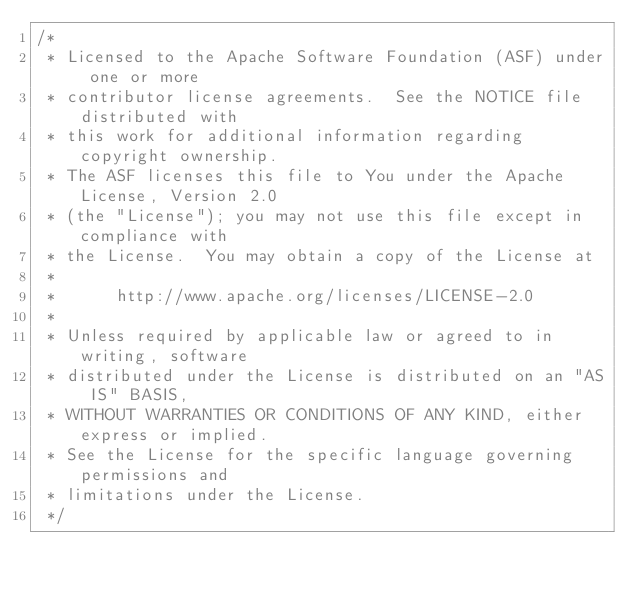Convert code to text. <code><loc_0><loc_0><loc_500><loc_500><_Java_>/*
 * Licensed to the Apache Software Foundation (ASF) under one or more
 * contributor license agreements.  See the NOTICE file distributed with
 * this work for additional information regarding copyright ownership.
 * The ASF licenses this file to You under the Apache License, Version 2.0
 * (the "License"); you may not use this file except in compliance with
 * the License.  You may obtain a copy of the License at
 * 
 *      http://www.apache.org/licenses/LICENSE-2.0
 * 
 * Unless required by applicable law or agreed to in writing, software
 * distributed under the License is distributed on an "AS IS" BASIS,
 * WITHOUT WARRANTIES OR CONDITIONS OF ANY KIND, either express or implied.
 * See the License for the specific language governing permissions and
 * limitations under the License.
 */

</code> 